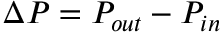<formula> <loc_0><loc_0><loc_500><loc_500>\Delta P = P _ { o u t } - P _ { i n }</formula> 